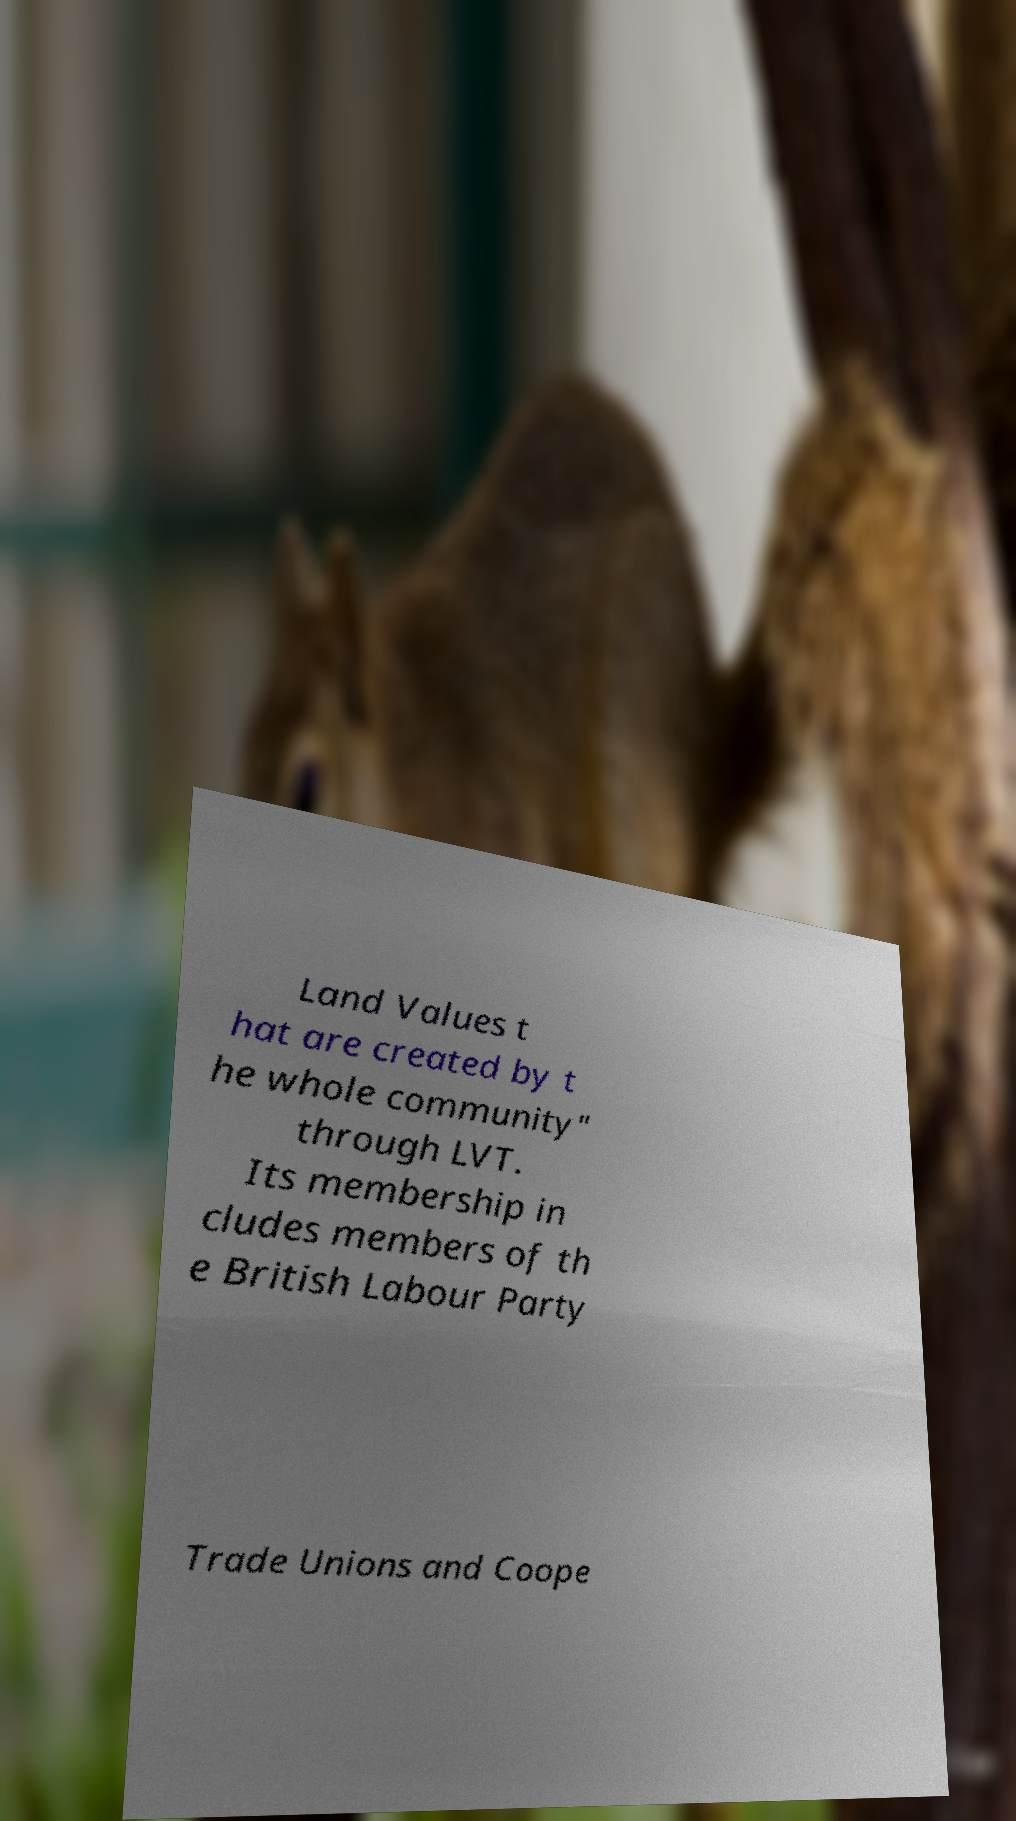Could you assist in decoding the text presented in this image and type it out clearly? Land Values t hat are created by t he whole community" through LVT. Its membership in cludes members of th e British Labour Party Trade Unions and Coope 